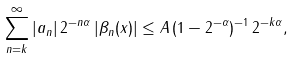<formula> <loc_0><loc_0><loc_500><loc_500>\sum _ { n = k } ^ { \infty } | a _ { n } | \, 2 ^ { - n \alpha } \, | \beta _ { n } ( x ) | \leq A \, ( 1 - 2 ^ { - \alpha } ) ^ { - 1 } \, 2 ^ { - k \alpha } ,</formula> 